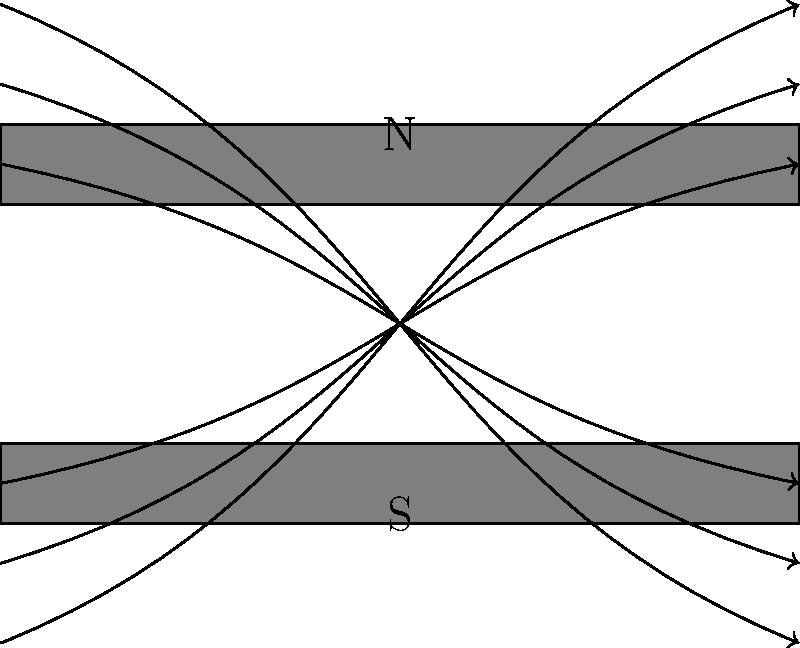In the context of voter behavior studies, how might the visualization of magnetic field lines using iron filings relate to the spread of political ideologies within a society? Consider the strength and direction of the field lines as analogous to societal factors influencing voter decisions. To answer this question, let's break down the analogy between magnetic field lines and the spread of political ideologies:

1. Magnetic field strength: The density of iron filings represents the strength of the magnetic field. In our societal analogy, this could represent the intensity of societal factors influencing voter behavior.

2. Field line direction: The arrows on the field lines show the direction of the magnetic field. In our analogy, this could represent the direction or trend of societal influences on political ideologies.

3. Pole strength: The concentration of field lines near the poles indicates stronger magnetic influence. This could be analogous to areas of strong societal influence on political ideologies.

4. Field line curvature: The curved nature of the field lines shows how the magnetic influence extends beyond the magnet itself. This could represent how societal factors extend their influence beyond their immediate source.

5. Symmetry: The symmetrical nature of the field lines could represent the balanced nature of opposing political ideologies in a society.

6. Interactions: Just as iron filings align with the magnetic field, individuals in a society might align with prevalent societal factors.

In the context of voter behavior studies, this visualization could be used to illustrate how societal factors (represented by the magnetic field) shape and direct political ideologies (represented by the iron filings). The strength and direction of these factors would be analogous to the magnetic field lines, showing how they influence and guide voter decisions across different segments of society.

This model supports the belief that societal factors supersede media influence in voter behavior, as it demonstrates a pervasive and structured force field (societal factors) shaping the overall pattern of ideological alignment (voter behavior).
Answer: Societal factors as pervasive force fields shaping voter ideology alignment 